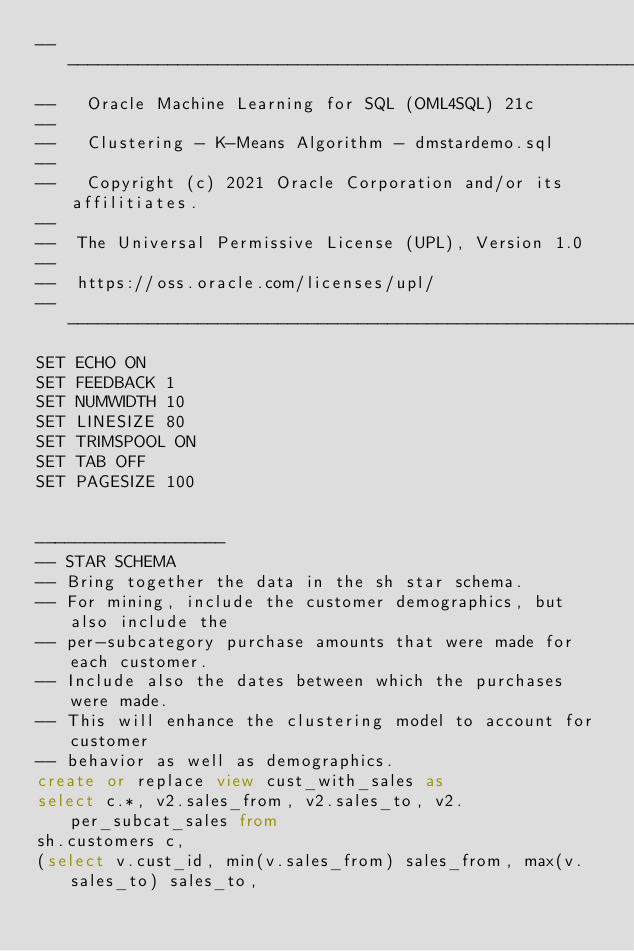<code> <loc_0><loc_0><loc_500><loc_500><_SQL_>-----------------------------------------------------------------------
--   Oracle Machine Learning for SQL (OML4SQL) 21c
-- 
--   Clustering - K-Means Algorithm - dmstardemo.sql
--   
--   Copyright (c) 2021 Oracle Corporation and/or its affilitiates.
--
--  The Universal Permissive License (UPL), Version 1.0
--
--  https://oss.oracle.com/licenses/upl/
-----------------------------------------------------------------------
SET ECHO ON
SET FEEDBACK 1
SET NUMWIDTH 10
SET LINESIZE 80
SET TRIMSPOOL ON
SET TAB OFF
SET PAGESIZE 100


-------------------
-- STAR SCHEMA
-- Bring together the data in the sh star schema.
-- For mining, include the customer demographics, but also include the
-- per-subcategory purchase amounts that were made for each customer.
-- Include also the dates between which the purchases were made.  
-- This will enhance the clustering model to account for customer
-- behavior as well as demographics.
create or replace view cust_with_sales as
select c.*, v2.sales_from, v2.sales_to, v2.per_subcat_sales from
sh.customers c,
(select v.cust_id, min(v.sales_from) sales_from, max(v.sales_to) sales_to,</code> 